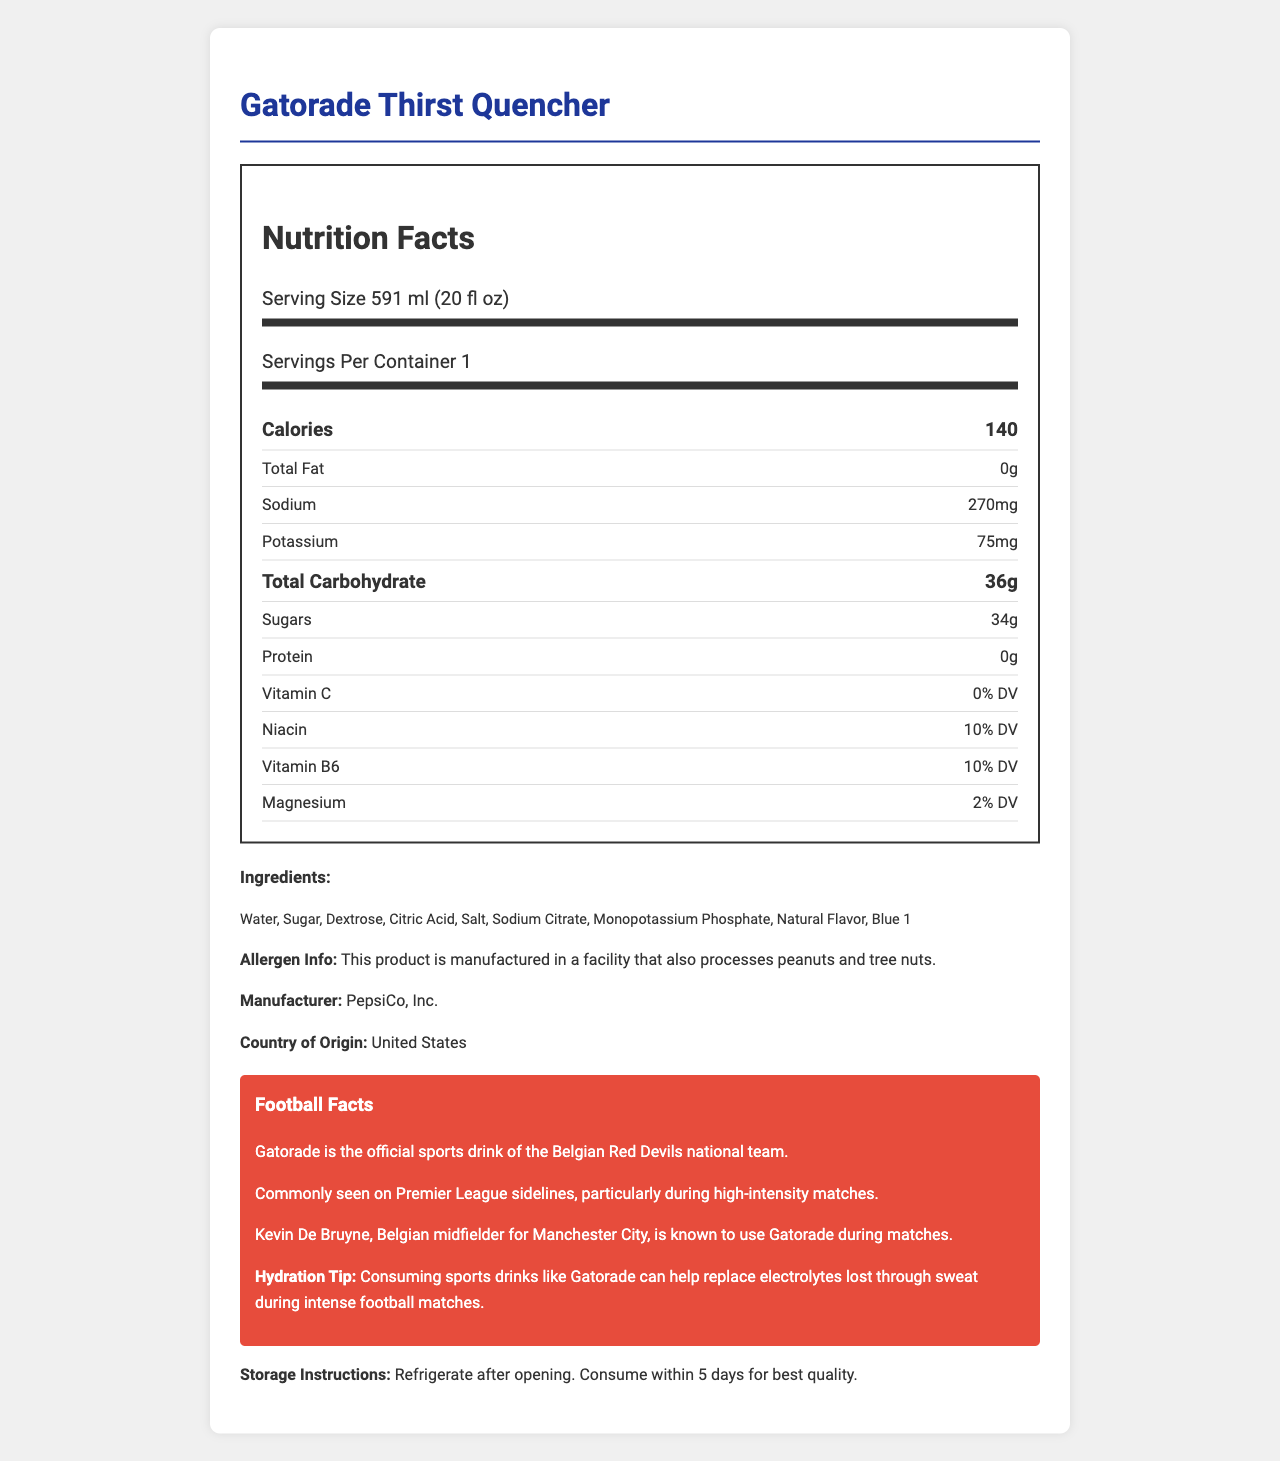what is the serving size of Gatorade Thirst Quencher? The serving size is clearly stated at the beginning of the nutrition label as "Serving Size 591 ml (20 fl oz)".
Answer: 591 ml (20 fl oz) how many calories are there per serving? The document shows the calories per serving as 140 in the major nutrient section.
Answer: 140 List three ingredients in Gatorade Thirst Quencher. The ingredient list specifies several ingredients, including Water, Sugar, and Dextrose.
Answer: Water, Sugar, Dextrose Which vitamin in Gatorade Thirst Quencher provides 10% of the Daily Value? Both Niacin and Vitamin B6 are mentioned as providing 10% of the Daily Value.
Answer: Niacin and Vitamin B6 What is the total carbohydrate content of Gatorade Thirst Quencher? The total carbohydrate content is listed as 36g in the nutrients section.
Answer: 36g Who manufactures Gatorade Thirst Quencher? A. Coca-Cola B. Nestlé C. PepsiCo, Inc. The manufacturer is explicitly mentioned as PepsiCo, Inc. in the document.
Answer: C. PepsiCo, Inc. What is the sodium content per serving? The sodium content per serving is listed as 270mg in the nutrients section.
Answer: 270mg Which Belgian national team is associated with Gatorade? A. Belgian Red Knights B. Belgian Red Lions C. Belgian Red Devils The document states that Gatorade is the official sports drink of the Belgian Red Devils national team.
Answer: C. Belgian Red Devils Is Gatorade Thirst Quencher free of fats? The nutritional label states that total fat content is 0g, indicating it is fat-free.
Answer: Yes What kind of flavoring does Gatorade Thirst Quencher contain? The ingredient list includes "Natural Flavor".
Answer: Natural Flavor Summarize the main information provided about Gatorade Thirst Quencher in the document. This summary captures key points including nutritional values, ingredients, manufacturer details, endorsements, and usage tips.
Answer: The nutrition facts label for Gatorade Thirst Quencher outlines its serving size of 591 ml (20 fl oz), providing 140 calories. It contains 0g fat, 270mg sodium, 75mg potassium, 36g total carbohydrate (including 34g sugars), and 0g protein. The ingredients include Water, Sugar, and Dextrose, among others. It provides 10% of the Daily Value for Niacin and Vitamin B6, and 2% for Magnesium. The label also mentions its allergen information, manufacturer as PepsiCo, Inc., its association with the Belgian Red Devils, and endorsement by Kevin De Bruyne. Additionally, it offers storage instructions to refrigerate after opening and consume within 5 days. What is the date of manufacture of this Gatorade bottle? The document does not provide any information about the date of manufacture.
Answer: Cannot be determined 